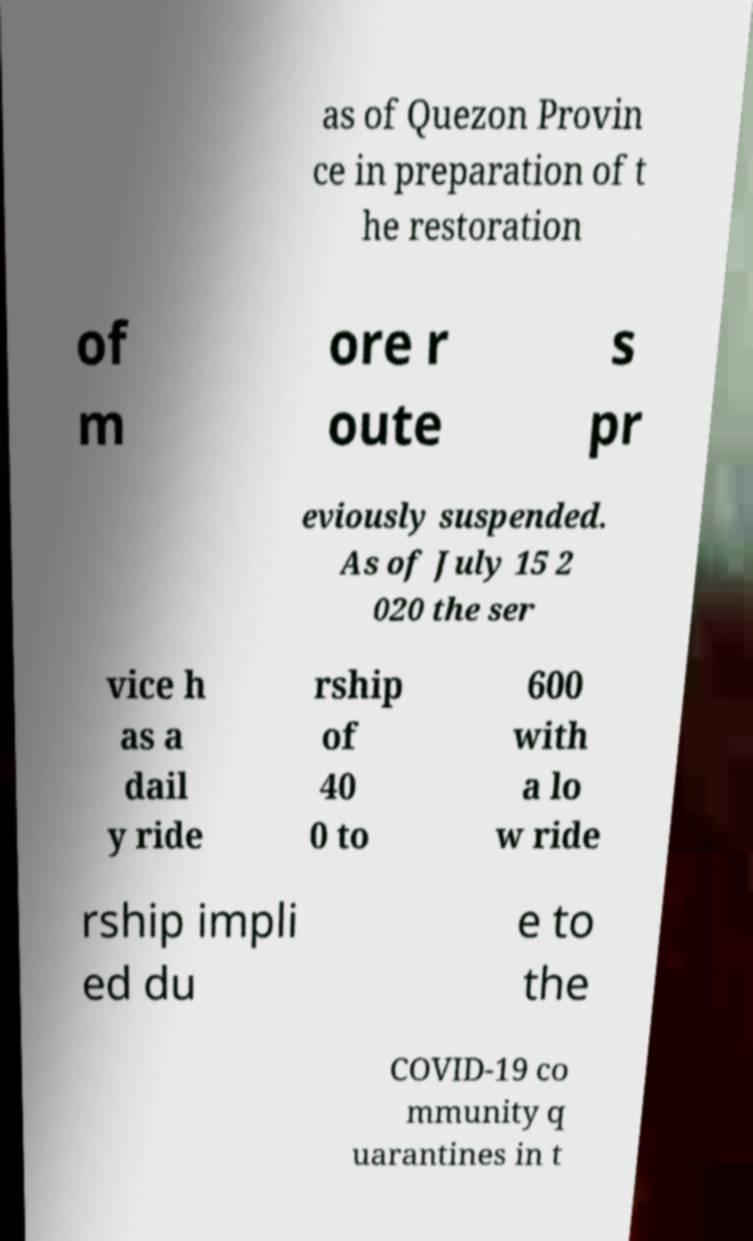What messages or text are displayed in this image? I need them in a readable, typed format. as of Quezon Provin ce in preparation of t he restoration of m ore r oute s pr eviously suspended. As of July 15 2 020 the ser vice h as a dail y ride rship of 40 0 to 600 with a lo w ride rship impli ed du e to the COVID-19 co mmunity q uarantines in t 